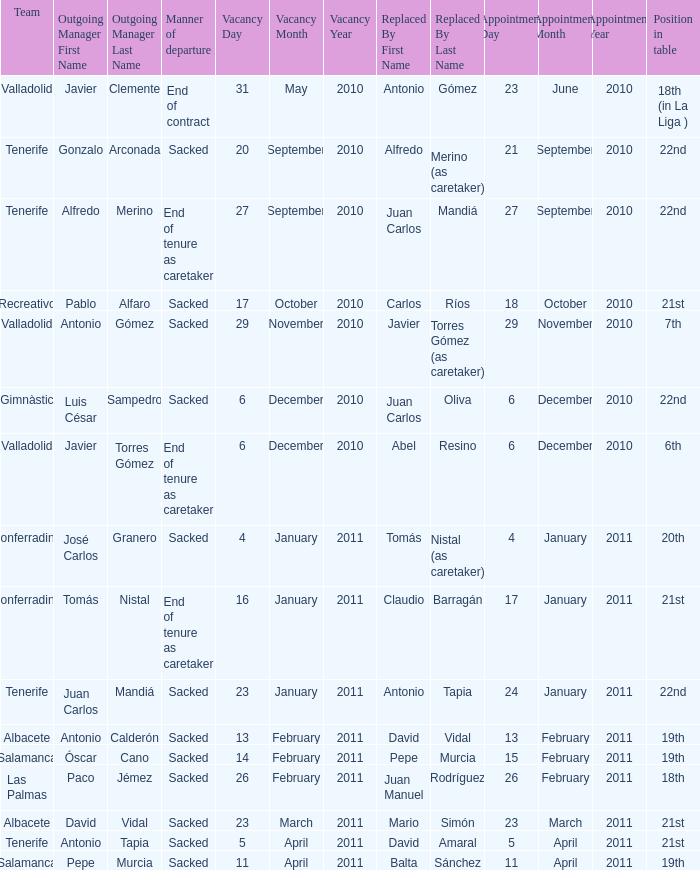What was the manner of departure for the appointment date of 21 september 2010 Sacked. 